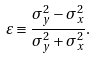<formula> <loc_0><loc_0><loc_500><loc_500>\varepsilon \equiv \frac { \sigma _ { y } ^ { 2 } - \sigma _ { x } ^ { 2 } } { \sigma _ { y } ^ { 2 } + \sigma _ { x } ^ { 2 } } .</formula> 